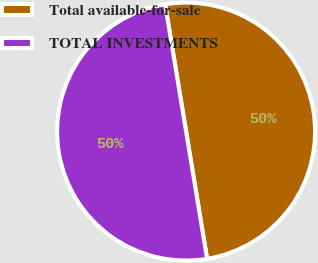Convert chart to OTSL. <chart><loc_0><loc_0><loc_500><loc_500><pie_chart><fcel>Total available-for-sale<fcel>TOTAL INVESTMENTS<nl><fcel>50.0%<fcel>50.0%<nl></chart> 